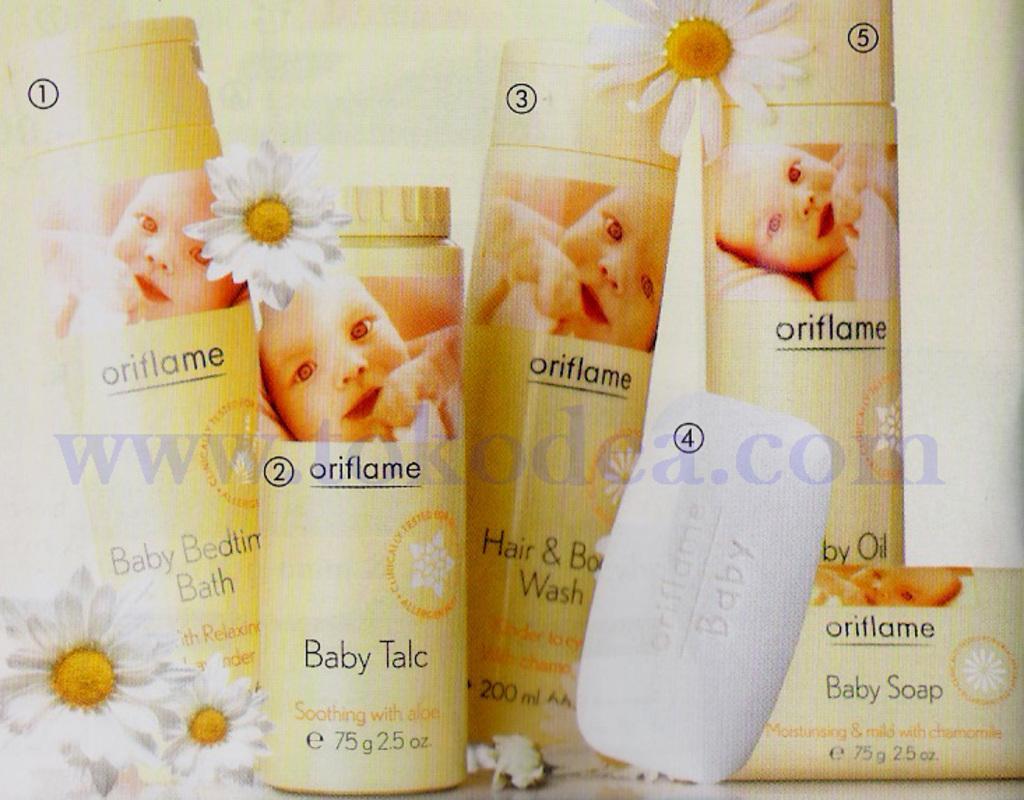In one or two sentences, can you explain what this image depicts? In this image, we can see few bottles, soap, flowers. it is a poster. In the middle of the image, we can see a watermark. These objects are labeled with numbers. 